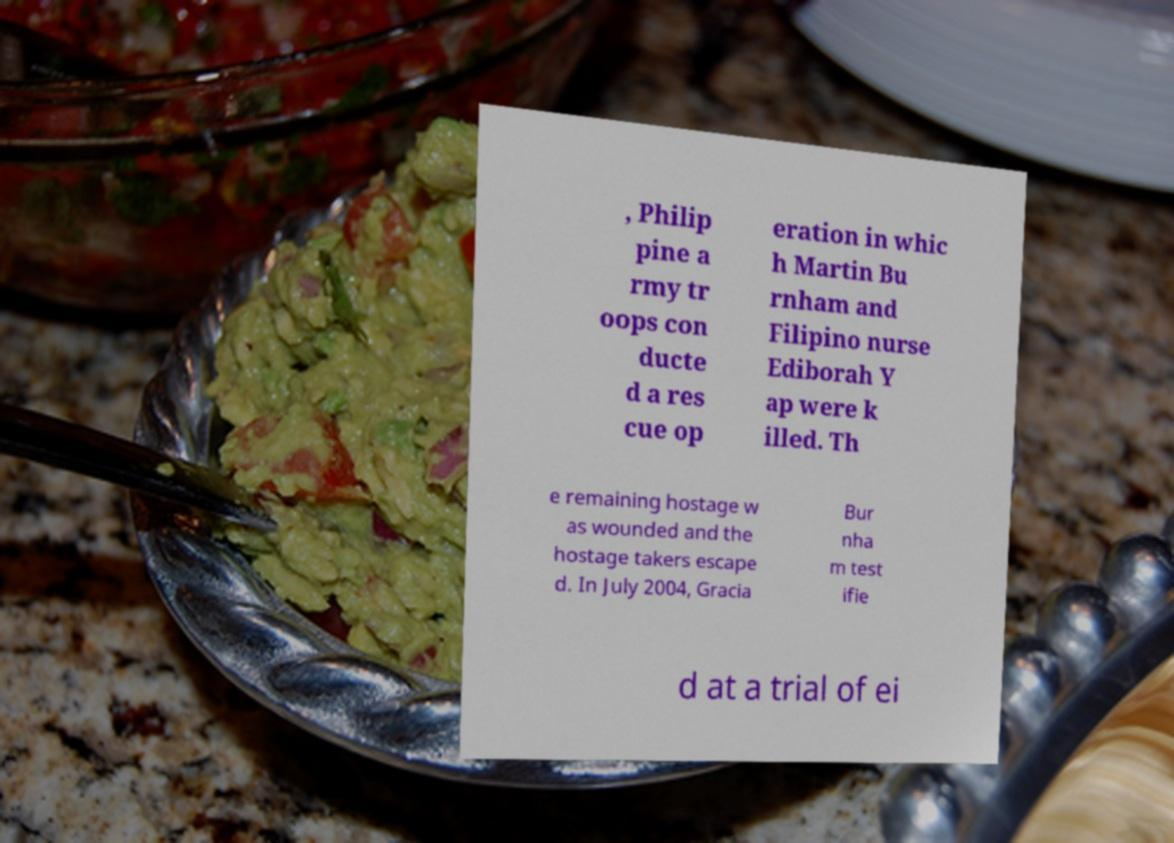Could you extract and type out the text from this image? , Philip pine a rmy tr oops con ducte d a res cue op eration in whic h Martin Bu rnham and Filipino nurse Ediborah Y ap were k illed. Th e remaining hostage w as wounded and the hostage takers escape d. In July 2004, Gracia Bur nha m test ifie d at a trial of ei 